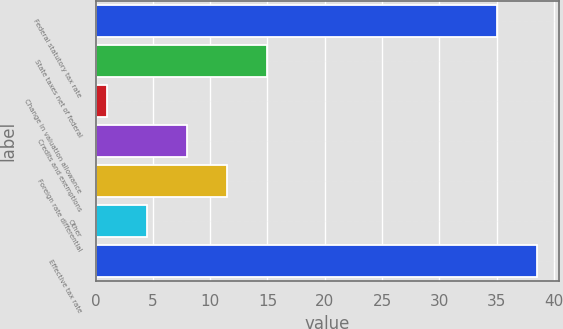<chart> <loc_0><loc_0><loc_500><loc_500><bar_chart><fcel>Federal statutory tax rate<fcel>State taxes net of federal<fcel>Change in valuation allowance<fcel>Credits and exemptions<fcel>Foreign rate differential<fcel>Other<fcel>Effective tax rate<nl><fcel>35<fcel>15<fcel>1<fcel>8<fcel>11.5<fcel>4.5<fcel>38.5<nl></chart> 